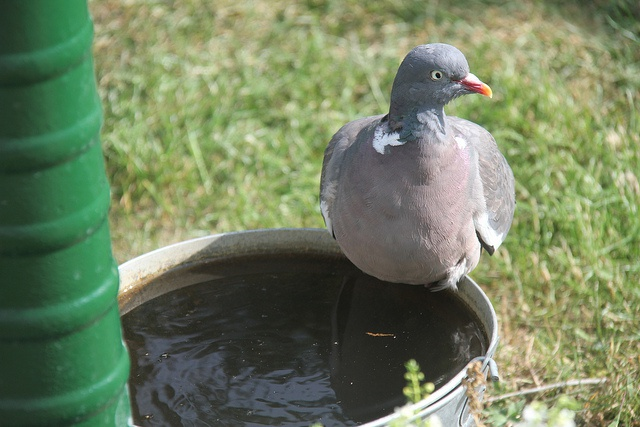Describe the objects in this image and their specific colors. I can see bowl in black, gray, and lightgray tones and bird in black, gray, lightgray, and darkgray tones in this image. 